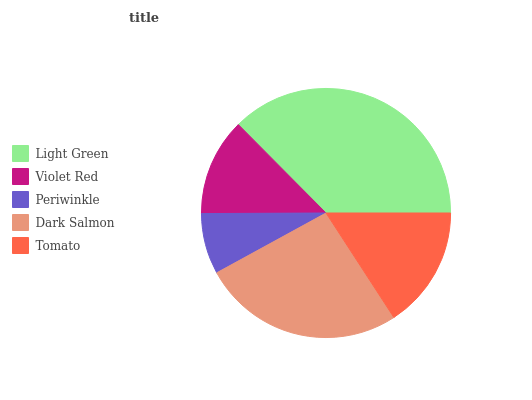Is Periwinkle the minimum?
Answer yes or no. Yes. Is Light Green the maximum?
Answer yes or no. Yes. Is Violet Red the minimum?
Answer yes or no. No. Is Violet Red the maximum?
Answer yes or no. No. Is Light Green greater than Violet Red?
Answer yes or no. Yes. Is Violet Red less than Light Green?
Answer yes or no. Yes. Is Violet Red greater than Light Green?
Answer yes or no. No. Is Light Green less than Violet Red?
Answer yes or no. No. Is Tomato the high median?
Answer yes or no. Yes. Is Tomato the low median?
Answer yes or no. Yes. Is Violet Red the high median?
Answer yes or no. No. Is Violet Red the low median?
Answer yes or no. No. 